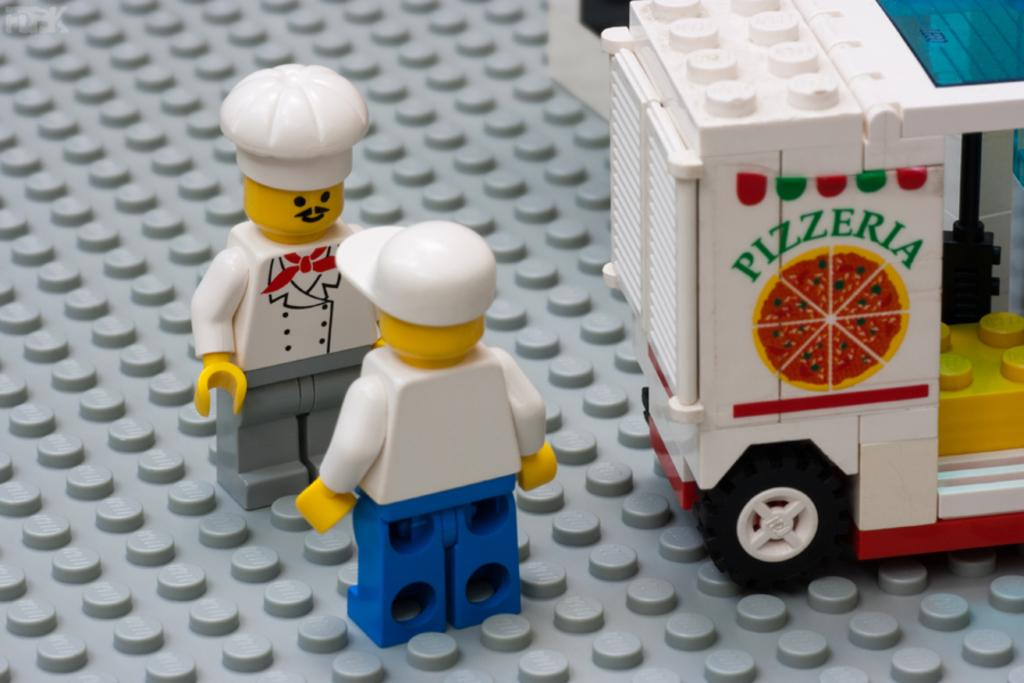What objects are in the center of the image? There are two toys in the center of the image. What type of toy can be seen on the right side of the image? There is a toy vehicle on the right side of the image. How many toads are visible in the image? There are no toads present in the image. What type of currency can be seen in the image? There is no currency visible in the image. 